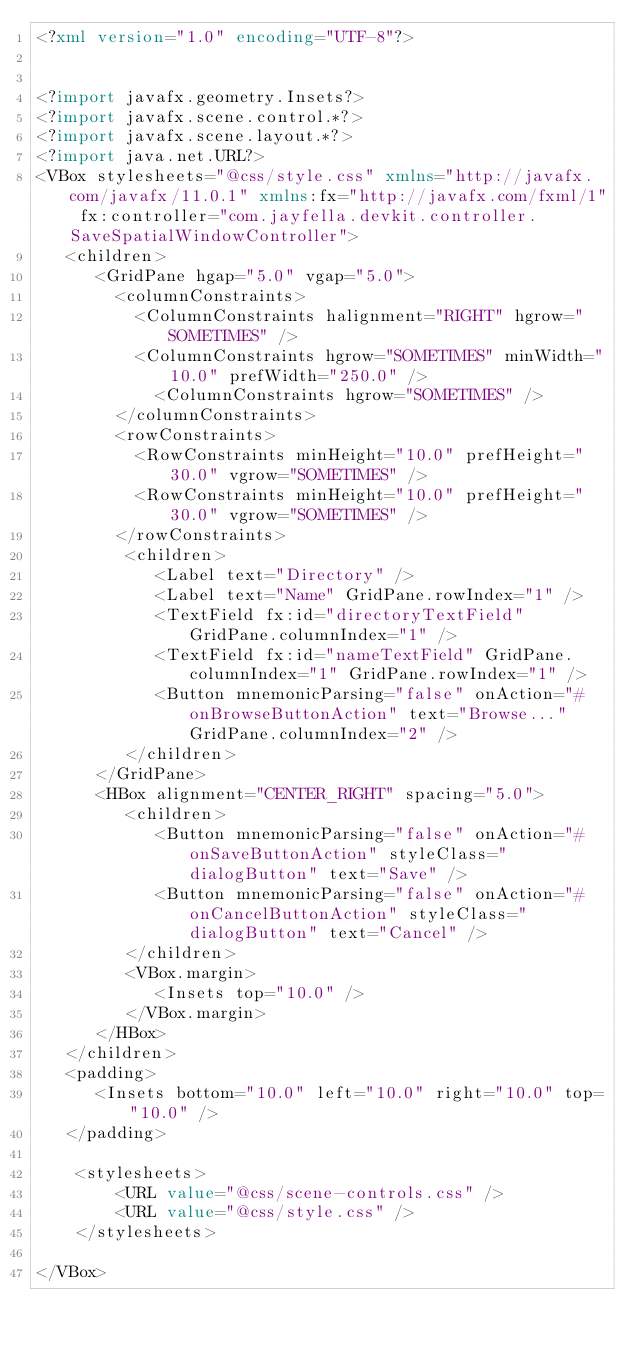<code> <loc_0><loc_0><loc_500><loc_500><_XML_><?xml version="1.0" encoding="UTF-8"?>


<?import javafx.geometry.Insets?>
<?import javafx.scene.control.*?>
<?import javafx.scene.layout.*?>
<?import java.net.URL?>
<VBox stylesheets="@css/style.css" xmlns="http://javafx.com/javafx/11.0.1" xmlns:fx="http://javafx.com/fxml/1" fx:controller="com.jayfella.devkit.controller.SaveSpatialWindowController">
   <children>
      <GridPane hgap="5.0" vgap="5.0">
        <columnConstraints>
          <ColumnConstraints halignment="RIGHT" hgrow="SOMETIMES" />
          <ColumnConstraints hgrow="SOMETIMES" minWidth="10.0" prefWidth="250.0" />
            <ColumnConstraints hgrow="SOMETIMES" />
        </columnConstraints>
        <rowConstraints>
          <RowConstraints minHeight="10.0" prefHeight="30.0" vgrow="SOMETIMES" />
          <RowConstraints minHeight="10.0" prefHeight="30.0" vgrow="SOMETIMES" />
        </rowConstraints>
         <children>
            <Label text="Directory" />
            <Label text="Name" GridPane.rowIndex="1" />
            <TextField fx:id="directoryTextField" GridPane.columnIndex="1" />
            <TextField fx:id="nameTextField" GridPane.columnIndex="1" GridPane.rowIndex="1" />
            <Button mnemonicParsing="false" onAction="#onBrowseButtonAction" text="Browse..." GridPane.columnIndex="2" />
         </children>
      </GridPane>
      <HBox alignment="CENTER_RIGHT" spacing="5.0">
         <children>
            <Button mnemonicParsing="false" onAction="#onSaveButtonAction" styleClass="dialogButton" text="Save" />
            <Button mnemonicParsing="false" onAction="#onCancelButtonAction" styleClass="dialogButton" text="Cancel" />
         </children>
         <VBox.margin>
            <Insets top="10.0" />
         </VBox.margin>
      </HBox>
   </children>
   <padding>
      <Insets bottom="10.0" left="10.0" right="10.0" top="10.0" />
   </padding>

    <stylesheets>
        <URL value="@css/scene-controls.css" />
        <URL value="@css/style.css" />
    </stylesheets>

</VBox>
</code> 